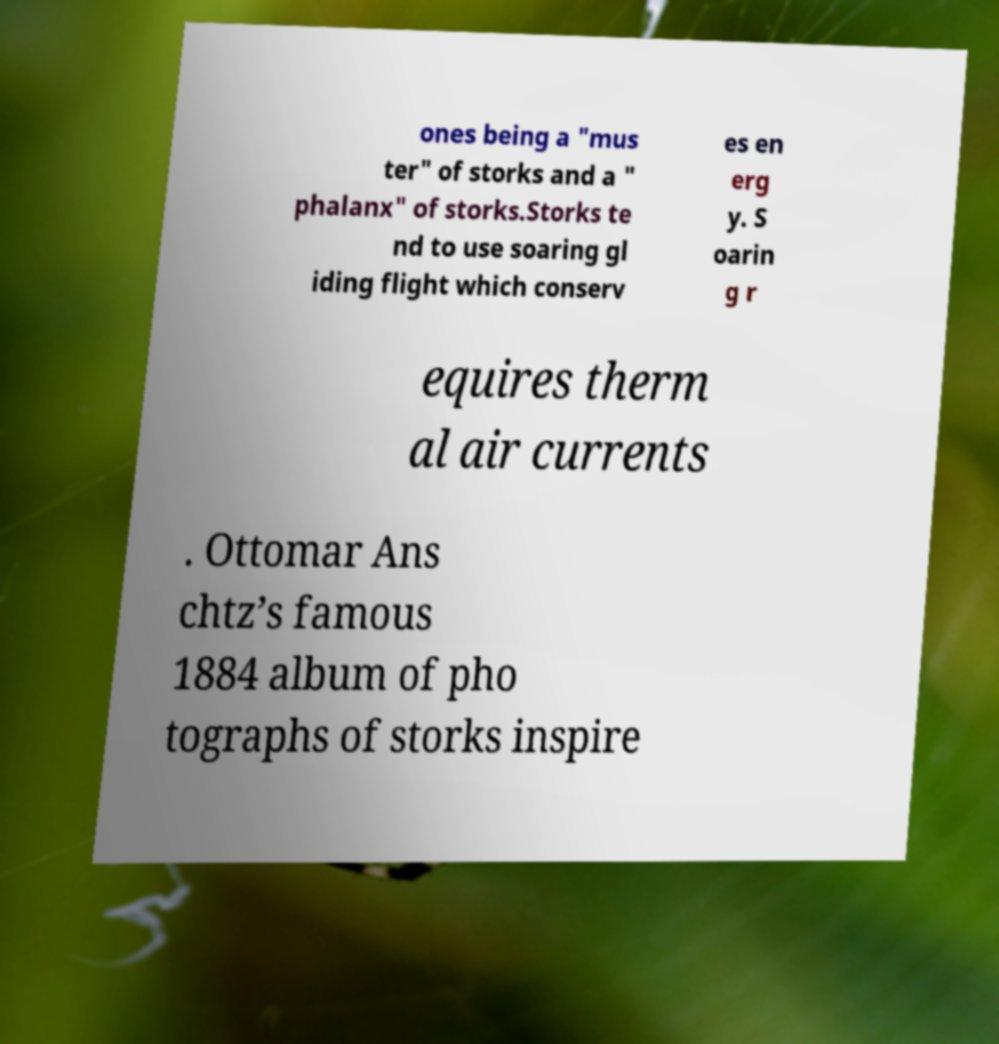There's text embedded in this image that I need extracted. Can you transcribe it verbatim? ones being a "mus ter" of storks and a " phalanx" of storks.Storks te nd to use soaring gl iding flight which conserv es en erg y. S oarin g r equires therm al air currents . Ottomar Ans chtz’s famous 1884 album of pho tographs of storks inspire 